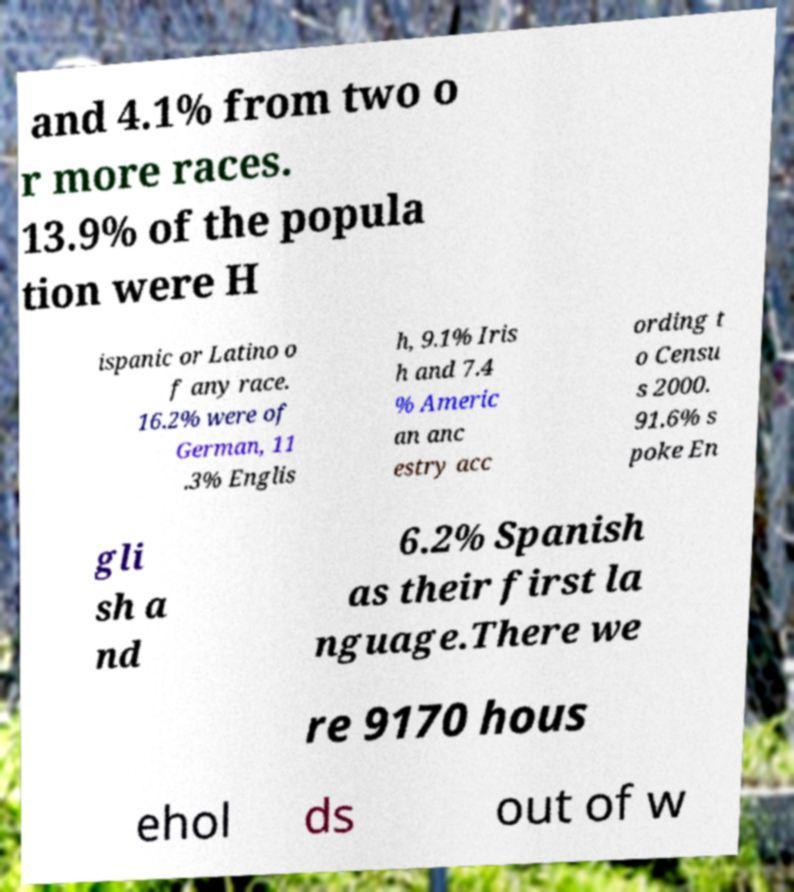Could you assist in decoding the text presented in this image and type it out clearly? and 4.1% from two o r more races. 13.9% of the popula tion were H ispanic or Latino o f any race. 16.2% were of German, 11 .3% Englis h, 9.1% Iris h and 7.4 % Americ an anc estry acc ording t o Censu s 2000. 91.6% s poke En gli sh a nd 6.2% Spanish as their first la nguage.There we re 9170 hous ehol ds out of w 